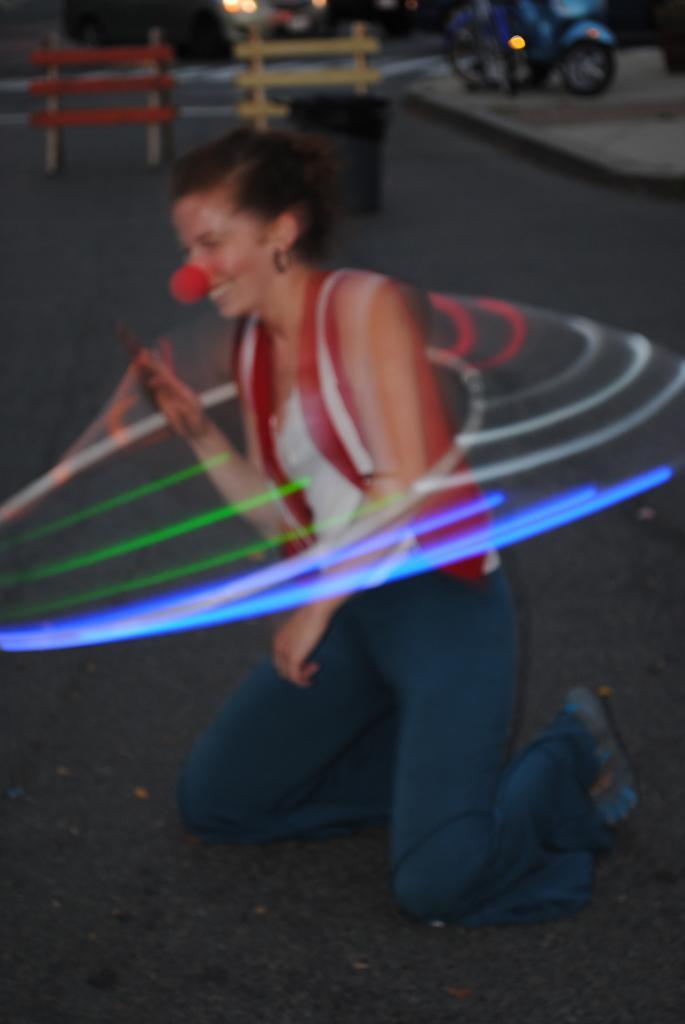Could you give a brief overview of what you see in this image? We can see a woman is standing on her knees on the road and there is a ring to her body and we can see lights around her and there is an object on her nose. In the background there is a dustbin on the road at the wooden stands. At the top the image is not clear but we can see vehicles on the ground and trees. 